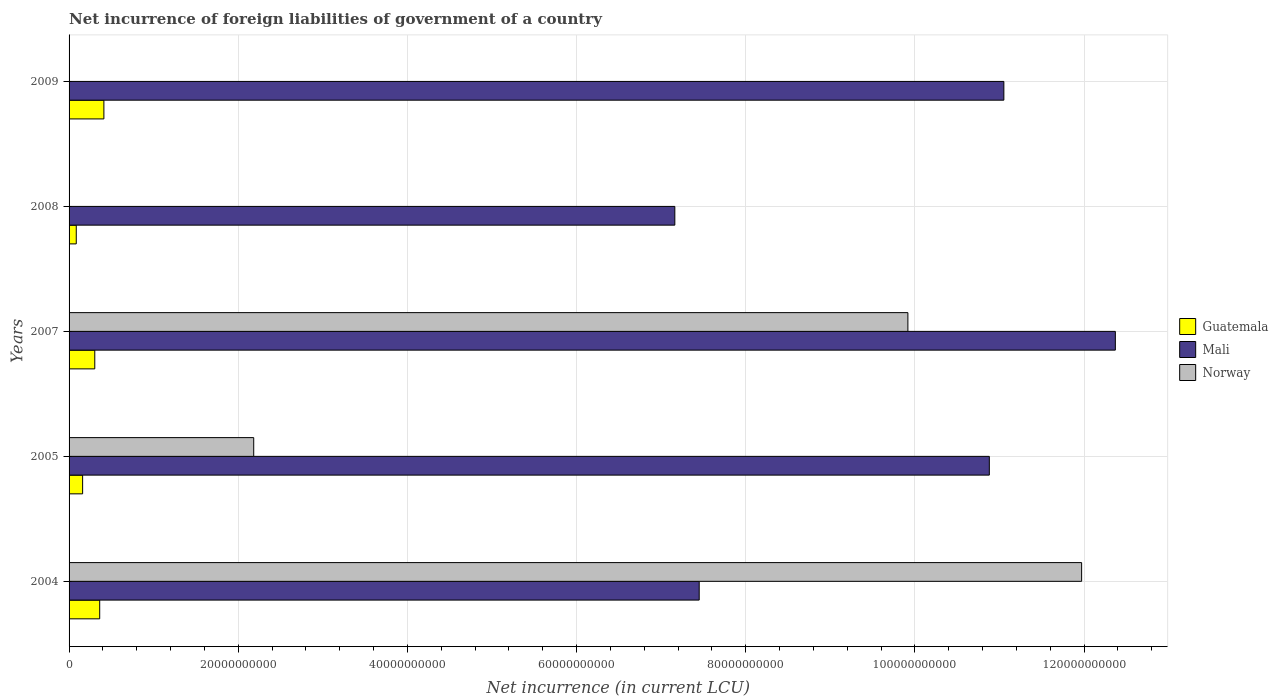Are the number of bars on each tick of the Y-axis equal?
Make the answer very short. No. How many bars are there on the 5th tick from the bottom?
Provide a succinct answer. 2. What is the net incurrence of foreign liabilities in Guatemala in 2005?
Ensure brevity in your answer.  1.60e+09. Across all years, what is the maximum net incurrence of foreign liabilities in Norway?
Provide a short and direct response. 1.20e+11. Across all years, what is the minimum net incurrence of foreign liabilities in Mali?
Offer a very short reply. 7.16e+1. What is the total net incurrence of foreign liabilities in Guatemala in the graph?
Make the answer very short. 1.32e+1. What is the difference between the net incurrence of foreign liabilities in Mali in 2005 and that in 2008?
Provide a succinct answer. 3.72e+1. What is the difference between the net incurrence of foreign liabilities in Norway in 2005 and the net incurrence of foreign liabilities in Guatemala in 2008?
Make the answer very short. 2.10e+1. What is the average net incurrence of foreign liabilities in Guatemala per year?
Offer a very short reply. 2.65e+09. In the year 2004, what is the difference between the net incurrence of foreign liabilities in Guatemala and net incurrence of foreign liabilities in Mali?
Keep it short and to the point. -7.09e+1. In how many years, is the net incurrence of foreign liabilities in Guatemala greater than 48000000000 LCU?
Your response must be concise. 0. What is the ratio of the net incurrence of foreign liabilities in Guatemala in 2007 to that in 2009?
Make the answer very short. 0.74. Is the difference between the net incurrence of foreign liabilities in Guatemala in 2007 and 2008 greater than the difference between the net incurrence of foreign liabilities in Mali in 2007 and 2008?
Provide a short and direct response. No. What is the difference between the highest and the second highest net incurrence of foreign liabilities in Guatemala?
Provide a succinct answer. 4.96e+08. What is the difference between the highest and the lowest net incurrence of foreign liabilities in Norway?
Your answer should be very brief. 1.20e+11. Is the sum of the net incurrence of foreign liabilities in Guatemala in 2005 and 2007 greater than the maximum net incurrence of foreign liabilities in Norway across all years?
Your response must be concise. No. How many bars are there?
Provide a short and direct response. 13. How many years are there in the graph?
Give a very brief answer. 5. Are the values on the major ticks of X-axis written in scientific E-notation?
Ensure brevity in your answer.  No. Does the graph contain any zero values?
Ensure brevity in your answer.  Yes. Does the graph contain grids?
Make the answer very short. Yes. How are the legend labels stacked?
Your answer should be compact. Vertical. What is the title of the graph?
Your response must be concise. Net incurrence of foreign liabilities of government of a country. Does "El Salvador" appear as one of the legend labels in the graph?
Your answer should be very brief. No. What is the label or title of the X-axis?
Offer a very short reply. Net incurrence (in current LCU). What is the Net incurrence (in current LCU) of Guatemala in 2004?
Offer a very short reply. 3.62e+09. What is the Net incurrence (in current LCU) of Mali in 2004?
Your response must be concise. 7.45e+1. What is the Net incurrence (in current LCU) in Norway in 2004?
Your response must be concise. 1.20e+11. What is the Net incurrence (in current LCU) in Guatemala in 2005?
Make the answer very short. 1.60e+09. What is the Net incurrence (in current LCU) in Mali in 2005?
Your answer should be very brief. 1.09e+11. What is the Net incurrence (in current LCU) in Norway in 2005?
Keep it short and to the point. 2.18e+1. What is the Net incurrence (in current LCU) in Guatemala in 2007?
Keep it short and to the point. 3.04e+09. What is the Net incurrence (in current LCU) in Mali in 2007?
Keep it short and to the point. 1.24e+11. What is the Net incurrence (in current LCU) of Norway in 2007?
Your answer should be very brief. 9.92e+1. What is the Net incurrence (in current LCU) of Guatemala in 2008?
Your response must be concise. 8.50e+08. What is the Net incurrence (in current LCU) in Mali in 2008?
Ensure brevity in your answer.  7.16e+1. What is the Net incurrence (in current LCU) of Norway in 2008?
Your answer should be compact. 0. What is the Net incurrence (in current LCU) of Guatemala in 2009?
Offer a very short reply. 4.12e+09. What is the Net incurrence (in current LCU) in Mali in 2009?
Keep it short and to the point. 1.11e+11. Across all years, what is the maximum Net incurrence (in current LCU) of Guatemala?
Provide a succinct answer. 4.12e+09. Across all years, what is the maximum Net incurrence (in current LCU) of Mali?
Offer a terse response. 1.24e+11. Across all years, what is the maximum Net incurrence (in current LCU) of Norway?
Your answer should be compact. 1.20e+11. Across all years, what is the minimum Net incurrence (in current LCU) of Guatemala?
Offer a very short reply. 8.50e+08. Across all years, what is the minimum Net incurrence (in current LCU) of Mali?
Provide a short and direct response. 7.16e+1. Across all years, what is the minimum Net incurrence (in current LCU) in Norway?
Your response must be concise. 0. What is the total Net incurrence (in current LCU) of Guatemala in the graph?
Offer a very short reply. 1.32e+1. What is the total Net incurrence (in current LCU) in Mali in the graph?
Your response must be concise. 4.89e+11. What is the total Net incurrence (in current LCU) in Norway in the graph?
Your answer should be very brief. 2.41e+11. What is the difference between the Net incurrence (in current LCU) in Guatemala in 2004 and that in 2005?
Give a very brief answer. 2.02e+09. What is the difference between the Net incurrence (in current LCU) of Mali in 2004 and that in 2005?
Your response must be concise. -3.43e+1. What is the difference between the Net incurrence (in current LCU) of Norway in 2004 and that in 2005?
Give a very brief answer. 9.79e+1. What is the difference between the Net incurrence (in current LCU) of Guatemala in 2004 and that in 2007?
Give a very brief answer. 5.80e+08. What is the difference between the Net incurrence (in current LCU) of Mali in 2004 and that in 2007?
Give a very brief answer. -4.92e+1. What is the difference between the Net incurrence (in current LCU) of Norway in 2004 and that in 2007?
Keep it short and to the point. 2.05e+1. What is the difference between the Net incurrence (in current LCU) of Guatemala in 2004 and that in 2008?
Make the answer very short. 2.77e+09. What is the difference between the Net incurrence (in current LCU) of Mali in 2004 and that in 2008?
Give a very brief answer. 2.88e+09. What is the difference between the Net incurrence (in current LCU) in Guatemala in 2004 and that in 2009?
Your answer should be very brief. -4.96e+08. What is the difference between the Net incurrence (in current LCU) in Mali in 2004 and that in 2009?
Your answer should be very brief. -3.60e+1. What is the difference between the Net incurrence (in current LCU) in Guatemala in 2005 and that in 2007?
Provide a succinct answer. -1.44e+09. What is the difference between the Net incurrence (in current LCU) in Mali in 2005 and that in 2007?
Offer a terse response. -1.49e+1. What is the difference between the Net incurrence (in current LCU) in Norway in 2005 and that in 2007?
Provide a succinct answer. -7.73e+1. What is the difference between the Net incurrence (in current LCU) in Guatemala in 2005 and that in 2008?
Offer a very short reply. 7.53e+08. What is the difference between the Net incurrence (in current LCU) in Mali in 2005 and that in 2008?
Provide a succinct answer. 3.72e+1. What is the difference between the Net incurrence (in current LCU) in Guatemala in 2005 and that in 2009?
Provide a short and direct response. -2.51e+09. What is the difference between the Net incurrence (in current LCU) in Mali in 2005 and that in 2009?
Provide a short and direct response. -1.72e+09. What is the difference between the Net incurrence (in current LCU) of Guatemala in 2007 and that in 2008?
Your response must be concise. 2.19e+09. What is the difference between the Net incurrence (in current LCU) of Mali in 2007 and that in 2008?
Your answer should be compact. 5.21e+1. What is the difference between the Net incurrence (in current LCU) in Guatemala in 2007 and that in 2009?
Your response must be concise. -1.08e+09. What is the difference between the Net incurrence (in current LCU) in Mali in 2007 and that in 2009?
Your answer should be compact. 1.32e+1. What is the difference between the Net incurrence (in current LCU) in Guatemala in 2008 and that in 2009?
Provide a short and direct response. -3.27e+09. What is the difference between the Net incurrence (in current LCU) of Mali in 2008 and that in 2009?
Give a very brief answer. -3.89e+1. What is the difference between the Net incurrence (in current LCU) of Guatemala in 2004 and the Net incurrence (in current LCU) of Mali in 2005?
Provide a short and direct response. -1.05e+11. What is the difference between the Net incurrence (in current LCU) in Guatemala in 2004 and the Net incurrence (in current LCU) in Norway in 2005?
Provide a succinct answer. -1.82e+1. What is the difference between the Net incurrence (in current LCU) in Mali in 2004 and the Net incurrence (in current LCU) in Norway in 2005?
Your response must be concise. 5.27e+1. What is the difference between the Net incurrence (in current LCU) of Guatemala in 2004 and the Net incurrence (in current LCU) of Mali in 2007?
Your answer should be very brief. -1.20e+11. What is the difference between the Net incurrence (in current LCU) of Guatemala in 2004 and the Net incurrence (in current LCU) of Norway in 2007?
Ensure brevity in your answer.  -9.56e+1. What is the difference between the Net incurrence (in current LCU) in Mali in 2004 and the Net incurrence (in current LCU) in Norway in 2007?
Ensure brevity in your answer.  -2.47e+1. What is the difference between the Net incurrence (in current LCU) in Guatemala in 2004 and the Net incurrence (in current LCU) in Mali in 2008?
Keep it short and to the point. -6.80e+1. What is the difference between the Net incurrence (in current LCU) in Guatemala in 2004 and the Net incurrence (in current LCU) in Mali in 2009?
Ensure brevity in your answer.  -1.07e+11. What is the difference between the Net incurrence (in current LCU) of Guatemala in 2005 and the Net incurrence (in current LCU) of Mali in 2007?
Make the answer very short. -1.22e+11. What is the difference between the Net incurrence (in current LCU) of Guatemala in 2005 and the Net incurrence (in current LCU) of Norway in 2007?
Your answer should be very brief. -9.76e+1. What is the difference between the Net incurrence (in current LCU) in Mali in 2005 and the Net incurrence (in current LCU) in Norway in 2007?
Provide a short and direct response. 9.63e+09. What is the difference between the Net incurrence (in current LCU) in Guatemala in 2005 and the Net incurrence (in current LCU) in Mali in 2008?
Provide a succinct answer. -7.00e+1. What is the difference between the Net incurrence (in current LCU) in Guatemala in 2005 and the Net incurrence (in current LCU) in Mali in 2009?
Provide a short and direct response. -1.09e+11. What is the difference between the Net incurrence (in current LCU) in Guatemala in 2007 and the Net incurrence (in current LCU) in Mali in 2008?
Offer a very short reply. -6.86e+1. What is the difference between the Net incurrence (in current LCU) of Guatemala in 2007 and the Net incurrence (in current LCU) of Mali in 2009?
Provide a short and direct response. -1.07e+11. What is the difference between the Net incurrence (in current LCU) of Guatemala in 2008 and the Net incurrence (in current LCU) of Mali in 2009?
Provide a short and direct response. -1.10e+11. What is the average Net incurrence (in current LCU) of Guatemala per year?
Provide a succinct answer. 2.65e+09. What is the average Net incurrence (in current LCU) of Mali per year?
Make the answer very short. 9.78e+1. What is the average Net incurrence (in current LCU) of Norway per year?
Your response must be concise. 4.81e+1. In the year 2004, what is the difference between the Net incurrence (in current LCU) in Guatemala and Net incurrence (in current LCU) in Mali?
Make the answer very short. -7.09e+1. In the year 2004, what is the difference between the Net incurrence (in current LCU) in Guatemala and Net incurrence (in current LCU) in Norway?
Provide a short and direct response. -1.16e+11. In the year 2004, what is the difference between the Net incurrence (in current LCU) of Mali and Net incurrence (in current LCU) of Norway?
Make the answer very short. -4.52e+1. In the year 2005, what is the difference between the Net incurrence (in current LCU) of Guatemala and Net incurrence (in current LCU) of Mali?
Your answer should be very brief. -1.07e+11. In the year 2005, what is the difference between the Net incurrence (in current LCU) in Guatemala and Net incurrence (in current LCU) in Norway?
Keep it short and to the point. -2.02e+1. In the year 2005, what is the difference between the Net incurrence (in current LCU) in Mali and Net incurrence (in current LCU) in Norway?
Your answer should be very brief. 8.70e+1. In the year 2007, what is the difference between the Net incurrence (in current LCU) of Guatemala and Net incurrence (in current LCU) of Mali?
Keep it short and to the point. -1.21e+11. In the year 2007, what is the difference between the Net incurrence (in current LCU) in Guatemala and Net incurrence (in current LCU) in Norway?
Give a very brief answer. -9.61e+1. In the year 2007, what is the difference between the Net incurrence (in current LCU) of Mali and Net incurrence (in current LCU) of Norway?
Your answer should be compact. 2.45e+1. In the year 2008, what is the difference between the Net incurrence (in current LCU) of Guatemala and Net incurrence (in current LCU) of Mali?
Offer a terse response. -7.08e+1. In the year 2009, what is the difference between the Net incurrence (in current LCU) of Guatemala and Net incurrence (in current LCU) of Mali?
Make the answer very short. -1.06e+11. What is the ratio of the Net incurrence (in current LCU) of Guatemala in 2004 to that in 2005?
Offer a very short reply. 2.26. What is the ratio of the Net incurrence (in current LCU) of Mali in 2004 to that in 2005?
Keep it short and to the point. 0.68. What is the ratio of the Net incurrence (in current LCU) in Norway in 2004 to that in 2005?
Your response must be concise. 5.48. What is the ratio of the Net incurrence (in current LCU) in Guatemala in 2004 to that in 2007?
Your response must be concise. 1.19. What is the ratio of the Net incurrence (in current LCU) in Mali in 2004 to that in 2007?
Provide a short and direct response. 0.6. What is the ratio of the Net incurrence (in current LCU) in Norway in 2004 to that in 2007?
Give a very brief answer. 1.21. What is the ratio of the Net incurrence (in current LCU) of Guatemala in 2004 to that in 2008?
Offer a very short reply. 4.26. What is the ratio of the Net incurrence (in current LCU) of Mali in 2004 to that in 2008?
Make the answer very short. 1.04. What is the ratio of the Net incurrence (in current LCU) of Guatemala in 2004 to that in 2009?
Give a very brief answer. 0.88. What is the ratio of the Net incurrence (in current LCU) of Mali in 2004 to that in 2009?
Offer a terse response. 0.67. What is the ratio of the Net incurrence (in current LCU) of Guatemala in 2005 to that in 2007?
Offer a very short reply. 0.53. What is the ratio of the Net incurrence (in current LCU) of Mali in 2005 to that in 2007?
Make the answer very short. 0.88. What is the ratio of the Net incurrence (in current LCU) of Norway in 2005 to that in 2007?
Provide a short and direct response. 0.22. What is the ratio of the Net incurrence (in current LCU) in Guatemala in 2005 to that in 2008?
Keep it short and to the point. 1.89. What is the ratio of the Net incurrence (in current LCU) of Mali in 2005 to that in 2008?
Give a very brief answer. 1.52. What is the ratio of the Net incurrence (in current LCU) of Guatemala in 2005 to that in 2009?
Your answer should be compact. 0.39. What is the ratio of the Net incurrence (in current LCU) in Mali in 2005 to that in 2009?
Make the answer very short. 0.98. What is the ratio of the Net incurrence (in current LCU) in Guatemala in 2007 to that in 2008?
Keep it short and to the point. 3.58. What is the ratio of the Net incurrence (in current LCU) in Mali in 2007 to that in 2008?
Provide a succinct answer. 1.73. What is the ratio of the Net incurrence (in current LCU) of Guatemala in 2007 to that in 2009?
Your answer should be compact. 0.74. What is the ratio of the Net incurrence (in current LCU) of Mali in 2007 to that in 2009?
Keep it short and to the point. 1.12. What is the ratio of the Net incurrence (in current LCU) of Guatemala in 2008 to that in 2009?
Ensure brevity in your answer.  0.21. What is the ratio of the Net incurrence (in current LCU) of Mali in 2008 to that in 2009?
Your response must be concise. 0.65. What is the difference between the highest and the second highest Net incurrence (in current LCU) in Guatemala?
Your answer should be compact. 4.96e+08. What is the difference between the highest and the second highest Net incurrence (in current LCU) of Mali?
Keep it short and to the point. 1.32e+1. What is the difference between the highest and the second highest Net incurrence (in current LCU) in Norway?
Your answer should be very brief. 2.05e+1. What is the difference between the highest and the lowest Net incurrence (in current LCU) in Guatemala?
Your answer should be compact. 3.27e+09. What is the difference between the highest and the lowest Net incurrence (in current LCU) in Mali?
Ensure brevity in your answer.  5.21e+1. What is the difference between the highest and the lowest Net incurrence (in current LCU) of Norway?
Your answer should be compact. 1.20e+11. 